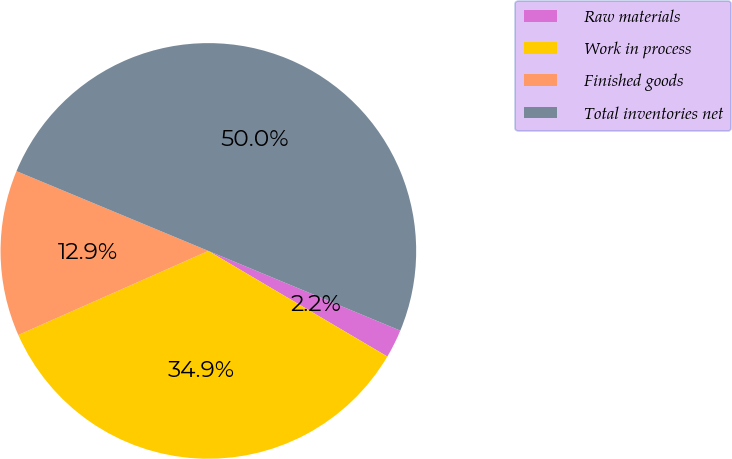Convert chart to OTSL. <chart><loc_0><loc_0><loc_500><loc_500><pie_chart><fcel>Raw materials<fcel>Work in process<fcel>Finished goods<fcel>Total inventories net<nl><fcel>2.22%<fcel>34.89%<fcel>12.9%<fcel>50.0%<nl></chart> 